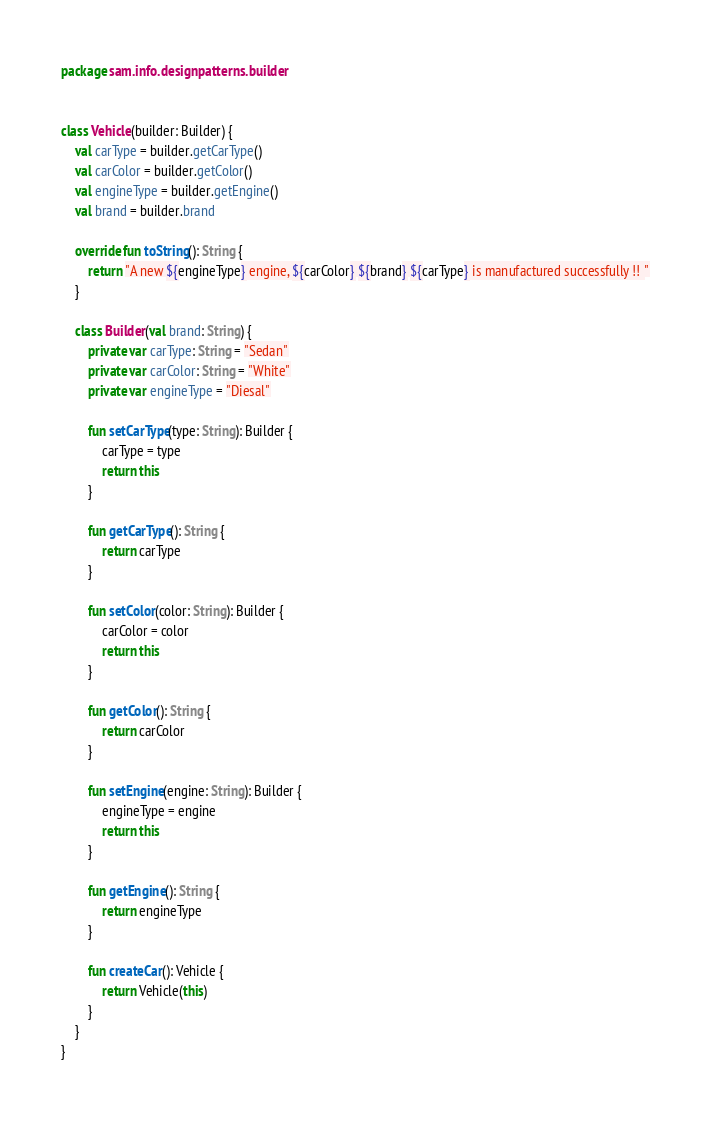<code> <loc_0><loc_0><loc_500><loc_500><_Kotlin_>package sam.info.designpatterns.builder


class Vehicle(builder: Builder) {
    val carType = builder.getCarType()
    val carColor = builder.getColor()
    val engineType = builder.getEngine()
    val brand = builder.brand

    override fun toString(): String {
        return "A new ${engineType} engine, ${carColor} ${brand} ${carType} is manufactured successfully !! "
    }

    class Builder(val brand: String) {
        private var carType: String = "Sedan"
        private var carColor: String = "White"
        private var engineType = "Diesal"

        fun setCarType(type: String): Builder {
            carType = type
            return this
        }

        fun getCarType(): String {
            return carType
        }

        fun setColor(color: String): Builder {
            carColor = color
            return this
        }

        fun getColor(): String {
            return carColor
        }

        fun setEngine(engine: String): Builder {
            engineType = engine
            return this
        }

        fun getEngine(): String {
            return engineType
        }

        fun createCar(): Vehicle {
            return Vehicle(this)
        }
    }
}</code> 